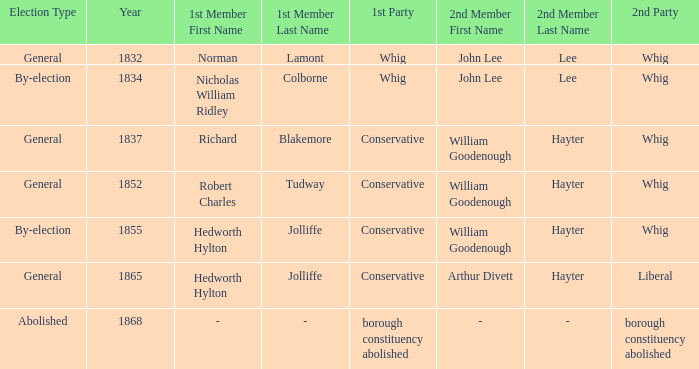What's the 2nd party of 2nd member william goodenough hayter when the 1st member is hedworth hylton jolliffe? Whig. 